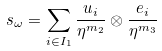Convert formula to latex. <formula><loc_0><loc_0><loc_500><loc_500>s _ { \omega } = \sum _ { i \in I _ { 1 } } \frac { u _ { i } } { \eta ^ { m _ { 2 } } } \otimes \frac { e _ { i } } { \eta ^ { m _ { 3 } } }</formula> 